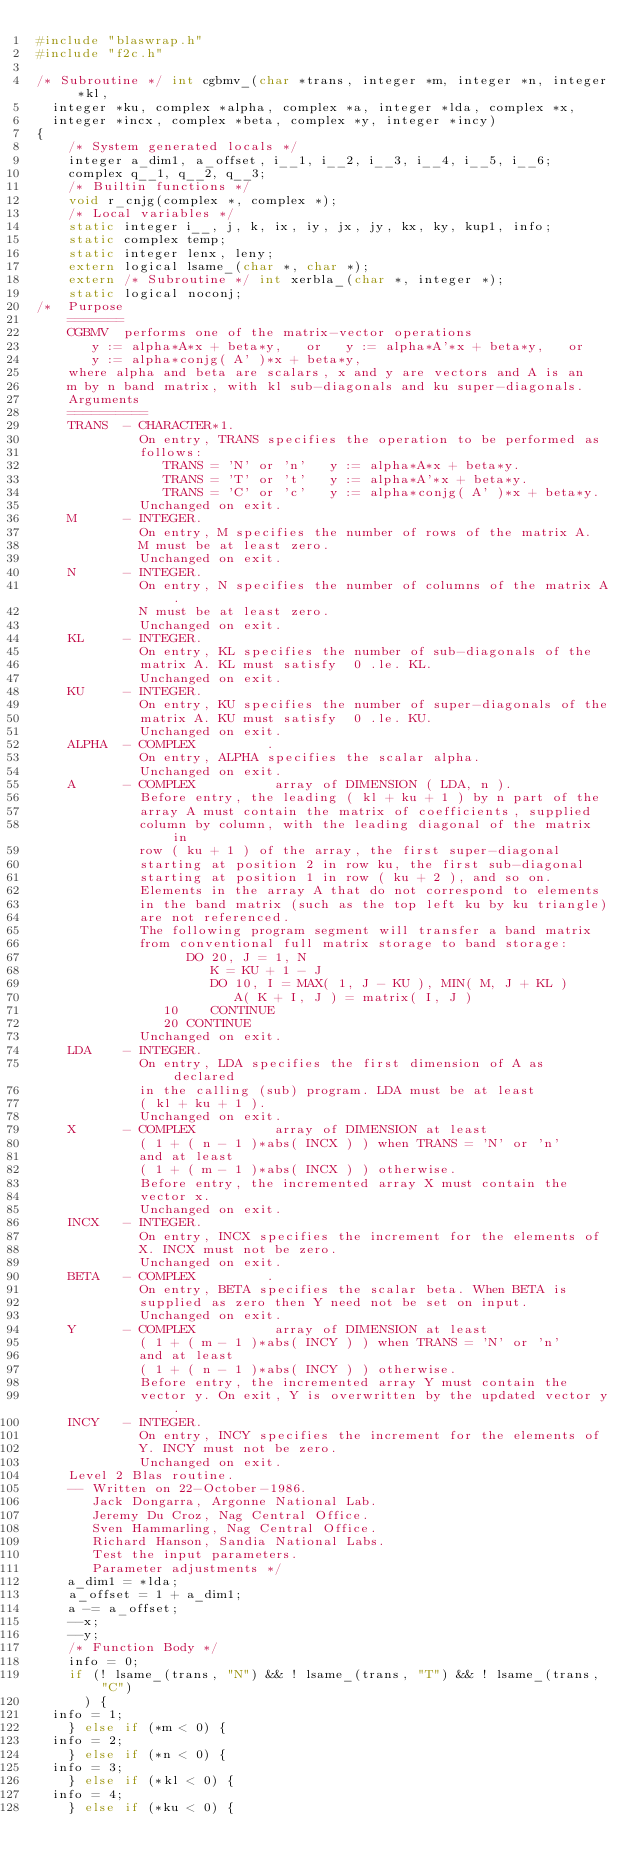<code> <loc_0><loc_0><loc_500><loc_500><_C_>#include "blaswrap.h"
#include "f2c.h"

/* Subroutine */ int cgbmv_(char *trans, integer *m, integer *n, integer *kl, 
	integer *ku, complex *alpha, complex *a, integer *lda, complex *x, 
	integer *incx, complex *beta, complex *y, integer *incy)
{
    /* System generated locals */
    integer a_dim1, a_offset, i__1, i__2, i__3, i__4, i__5, i__6;
    complex q__1, q__2, q__3;
    /* Builtin functions */
    void r_cnjg(complex *, complex *);
    /* Local variables */
    static integer i__, j, k, ix, iy, jx, jy, kx, ky, kup1, info;
    static complex temp;
    static integer lenx, leny;
    extern logical lsame_(char *, char *);
    extern /* Subroutine */ int xerbla_(char *, integer *);
    static logical noconj;
/*  Purpose   
    =======   
    CGBMV  performs one of the matrix-vector operations   
       y := alpha*A*x + beta*y,   or   y := alpha*A'*x + beta*y,   or   
       y := alpha*conjg( A' )*x + beta*y,   
    where alpha and beta are scalars, x and y are vectors and A is an   
    m by n band matrix, with kl sub-diagonals and ku super-diagonals.   
    Arguments   
    ==========   
    TRANS  - CHARACTER*1.   
             On entry, TRANS specifies the operation to be performed as   
             follows:   
                TRANS = 'N' or 'n'   y := alpha*A*x + beta*y.   
                TRANS = 'T' or 't'   y := alpha*A'*x + beta*y.   
                TRANS = 'C' or 'c'   y := alpha*conjg( A' )*x + beta*y.   
             Unchanged on exit.   
    M      - INTEGER.   
             On entry, M specifies the number of rows of the matrix A.   
             M must be at least zero.   
             Unchanged on exit.   
    N      - INTEGER.   
             On entry, N specifies the number of columns of the matrix A.   
             N must be at least zero.   
             Unchanged on exit.   
    KL     - INTEGER.   
             On entry, KL specifies the number of sub-diagonals of the   
             matrix A. KL must satisfy  0 .le. KL.   
             Unchanged on exit.   
    KU     - INTEGER.   
             On entry, KU specifies the number of super-diagonals of the   
             matrix A. KU must satisfy  0 .le. KU.   
             Unchanged on exit.   
    ALPHA  - COMPLEX         .   
             On entry, ALPHA specifies the scalar alpha.   
             Unchanged on exit.   
    A      - COMPLEX          array of DIMENSION ( LDA, n ).   
             Before entry, the leading ( kl + ku + 1 ) by n part of the   
             array A must contain the matrix of coefficients, supplied   
             column by column, with the leading diagonal of the matrix in   
             row ( ku + 1 ) of the array, the first super-diagonal   
             starting at position 2 in row ku, the first sub-diagonal   
             starting at position 1 in row ( ku + 2 ), and so on.   
             Elements in the array A that do not correspond to elements   
             in the band matrix (such as the top left ku by ku triangle)   
             are not referenced.   
             The following program segment will transfer a band matrix   
             from conventional full matrix storage to band storage:   
                   DO 20, J = 1, N   
                      K = KU + 1 - J   
                      DO 10, I = MAX( 1, J - KU ), MIN( M, J + KL )   
                         A( K + I, J ) = matrix( I, J )   
                10    CONTINUE   
                20 CONTINUE   
             Unchanged on exit.   
    LDA    - INTEGER.   
             On entry, LDA specifies the first dimension of A as declared   
             in the calling (sub) program. LDA must be at least   
             ( kl + ku + 1 ).   
             Unchanged on exit.   
    X      - COMPLEX          array of DIMENSION at least   
             ( 1 + ( n - 1 )*abs( INCX ) ) when TRANS = 'N' or 'n'   
             and at least   
             ( 1 + ( m - 1 )*abs( INCX ) ) otherwise.   
             Before entry, the incremented array X must contain the   
             vector x.   
             Unchanged on exit.   
    INCX   - INTEGER.   
             On entry, INCX specifies the increment for the elements of   
             X. INCX must not be zero.   
             Unchanged on exit.   
    BETA   - COMPLEX         .   
             On entry, BETA specifies the scalar beta. When BETA is   
             supplied as zero then Y need not be set on input.   
             Unchanged on exit.   
    Y      - COMPLEX          array of DIMENSION at least   
             ( 1 + ( m - 1 )*abs( INCY ) ) when TRANS = 'N' or 'n'   
             and at least   
             ( 1 + ( n - 1 )*abs( INCY ) ) otherwise.   
             Before entry, the incremented array Y must contain the   
             vector y. On exit, Y is overwritten by the updated vector y.   
    INCY   - INTEGER.   
             On entry, INCY specifies the increment for the elements of   
             Y. INCY must not be zero.   
             Unchanged on exit.   
    Level 2 Blas routine.   
    -- Written on 22-October-1986.   
       Jack Dongarra, Argonne National Lab.   
       Jeremy Du Croz, Nag Central Office.   
       Sven Hammarling, Nag Central Office.   
       Richard Hanson, Sandia National Labs.   
       Test the input parameters.   
       Parameter adjustments */
    a_dim1 = *lda;
    a_offset = 1 + a_dim1;
    a -= a_offset;
    --x;
    --y;
    /* Function Body */
    info = 0;
    if (! lsame_(trans, "N") && ! lsame_(trans, "T") && ! lsame_(trans, "C")
	    ) {
	info = 1;
    } else if (*m < 0) {
	info = 2;
    } else if (*n < 0) {
	info = 3;
    } else if (*kl < 0) {
	info = 4;
    } else if (*ku < 0) {</code> 